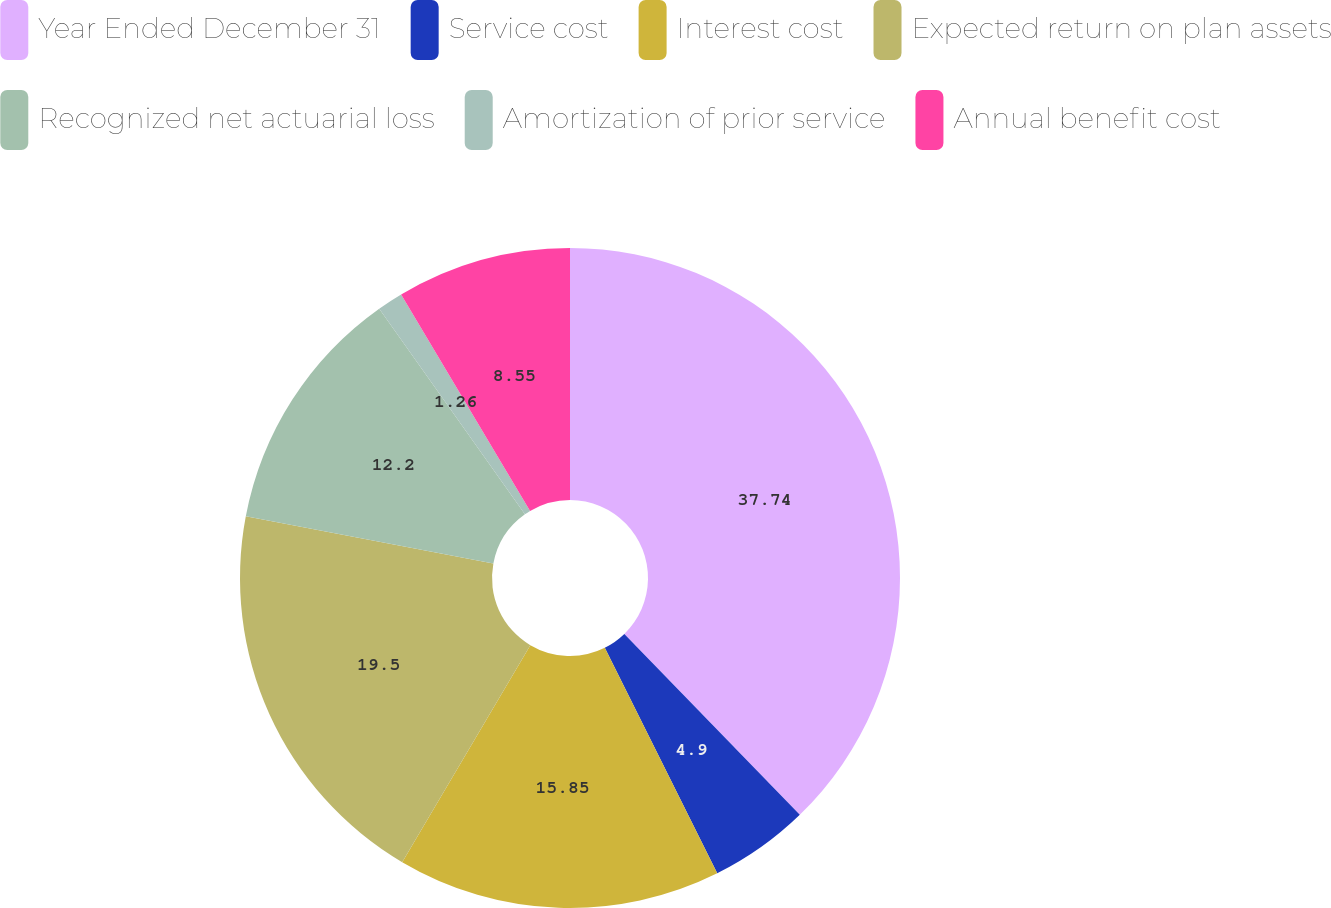Convert chart. <chart><loc_0><loc_0><loc_500><loc_500><pie_chart><fcel>Year Ended December 31<fcel>Service cost<fcel>Interest cost<fcel>Expected return on plan assets<fcel>Recognized net actuarial loss<fcel>Amortization of prior service<fcel>Annual benefit cost<nl><fcel>37.74%<fcel>4.9%<fcel>15.85%<fcel>19.5%<fcel>12.2%<fcel>1.26%<fcel>8.55%<nl></chart> 